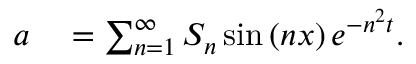Convert formula to latex. <formula><loc_0><loc_0><loc_500><loc_500>\begin{array} { r l } { a } & = \sum _ { n = 1 } ^ { \infty } S _ { n } \sin \left ( n x \right ) e ^ { - n ^ { 2 } t } . } \end{array}</formula> 